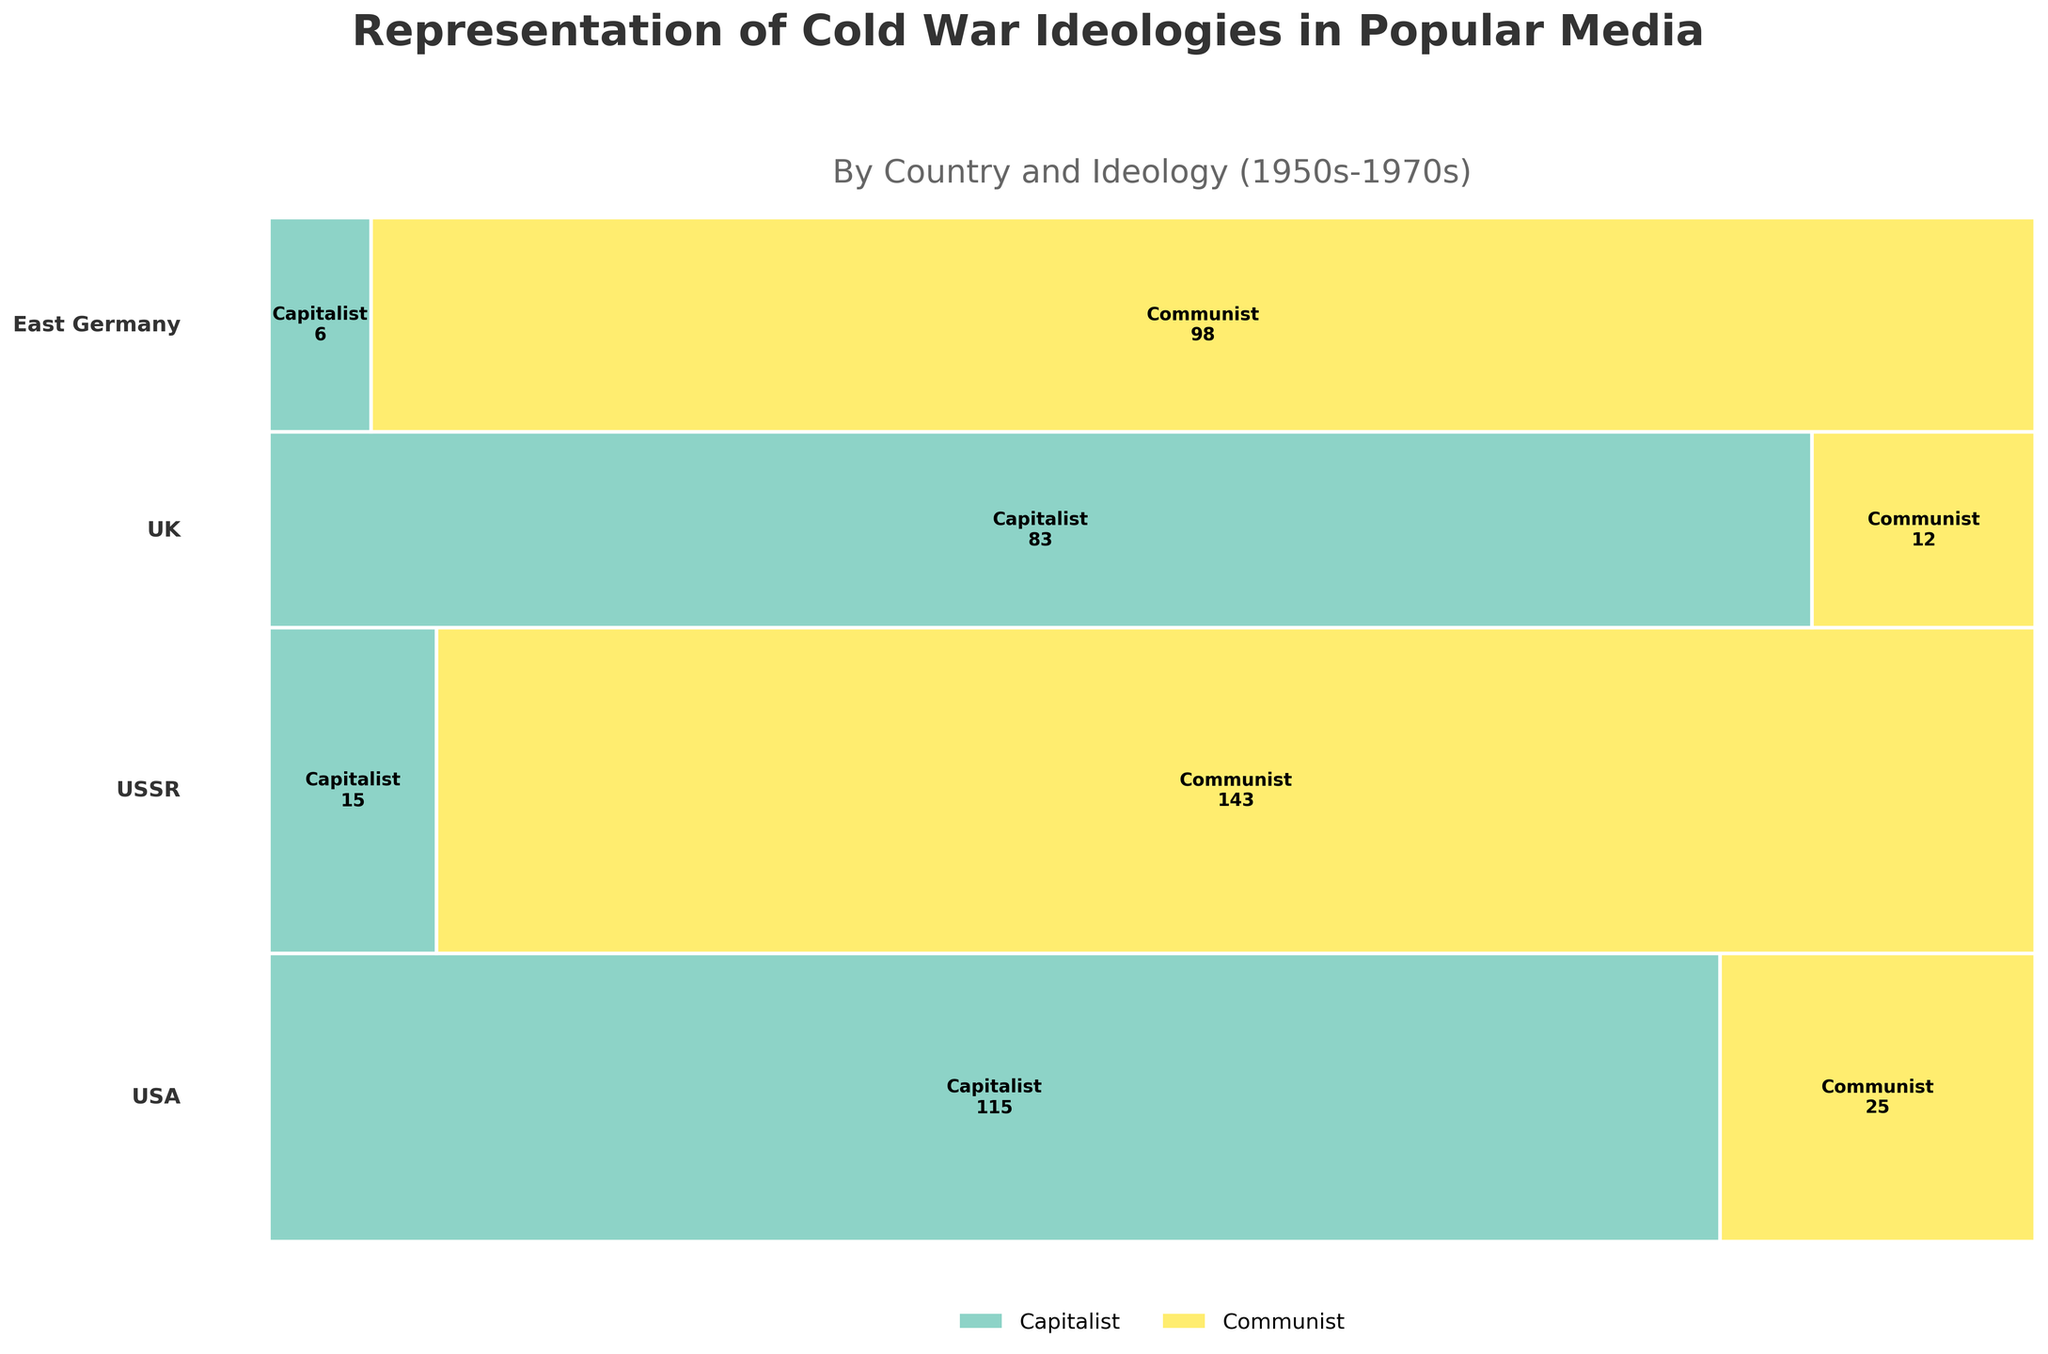What countries are represented in the mosaic plot? The countries are indicated by the labels next to each row in the mosaic plot. Look for text labels on the left side of the figure.
Answer: USA, USSR, UK, East Germany Which ideology has the largest representation in USA popular media during the 1950s? To determine this, look at the width of the sections within the USA row for the 1950s period. The wider section represents the larger frequency.
Answer: Capitalist How does the representation of Communist ideology in USSR's popular media change from the 1950s to the 1970s? To find the change, observe the widths of the Communist ideology sections for the USSR across the time periods. Compare the widths to see if they increase, decrease, or remain the same.
Answer: Decreases Which country has the most balanced representation of both ideologies in any time period? Check for the country and time period where the widths of the sections for both ideologies are most similar. This means both ideologies have nearly equal representation.
Answer: USA in the 1970s In which time period did East Germany have the highest representation of Capitalist ideology in its popular media? Identify which period has the widest section for Capitalist ideology within East Germany’s row.
Answer: 1970s Compare the representation of Capitalist ideology in TV shows between UK and East Germany during the 1950s. Examine the widths of Capitalist ideology sections in the rows for UK and East Germany in the 1950s. The wider section indicates greater representation.
Answer: UK has more representation Which country shows the least representation of Communist ideology in the 1960s? Look at the widths of the Communist sections for each country in the 1960s. The smallest width indicates the least representation.
Answer: UK Across all time periods, which ideology was most frequently represented in the USSR’s popular media? Look at the total width of each ideology section for the USSR across all time periods. The ideology with the widest total section is the most frequently represented.
Answer: Communist How does the representation of Capitalist ideology in UK popular media compare between the 1950s and the 1970s? Compare the widths of the Capitalist ideology sections in the UK row for the 1950s and the 1970s. Determine if the width increases, decreases, or remains the same.
Answer: Decreases What overall trend can be observed about the representation of Communist ideology in the USA’s popular media from the 1950s to the 1970s? Observe the changes in widths of the Communist ideology sections in the USA’s row across the three time periods. Compare the widths to identify an increasing or decreasing trend.
Answer: Increases 